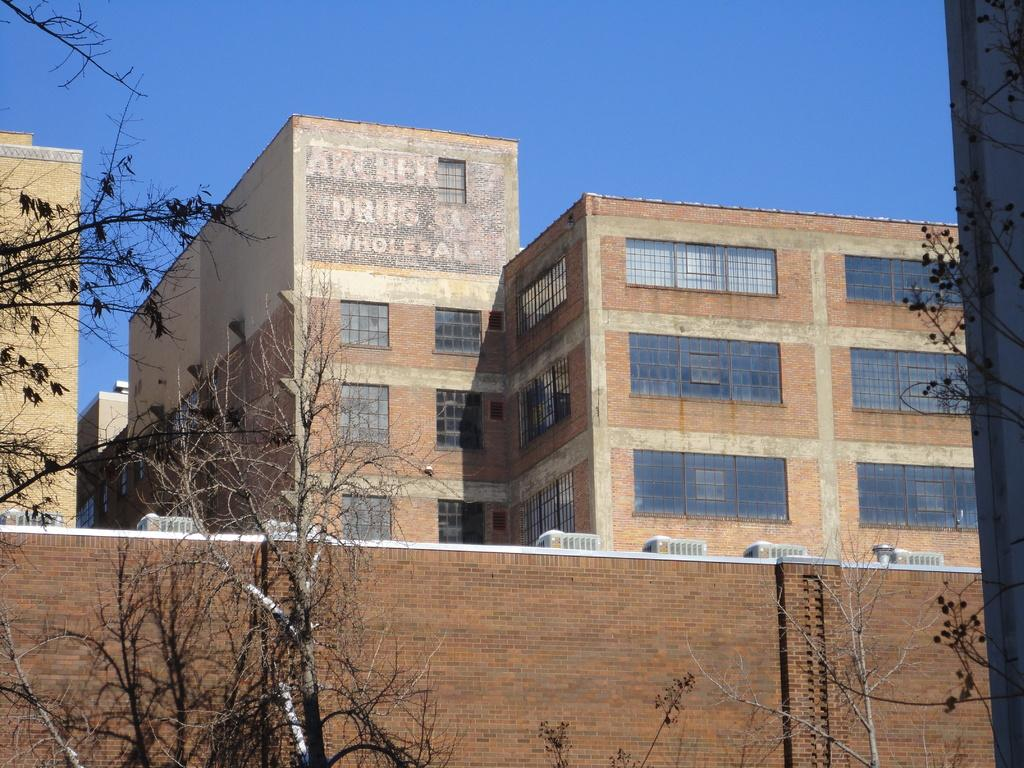What type of natural elements can be seen in the image? There are trees in the image. What is the color of the wall in the image? The wall in the image is brown. What type of structures can be seen in the background of the image? There are buildings in the background of the image. What colors are the buildings in the image? The buildings are brown and cream in color. What part of the natural environment is visible in the image? The sky is visible in the background of the image. What type of chalk is being used to draw on the wall in the image? There is no chalk or drawing present on the wall in the image. How does the debt affect the buildings in the image? There is no mention of debt in the image, and it does not affect the buildings. 